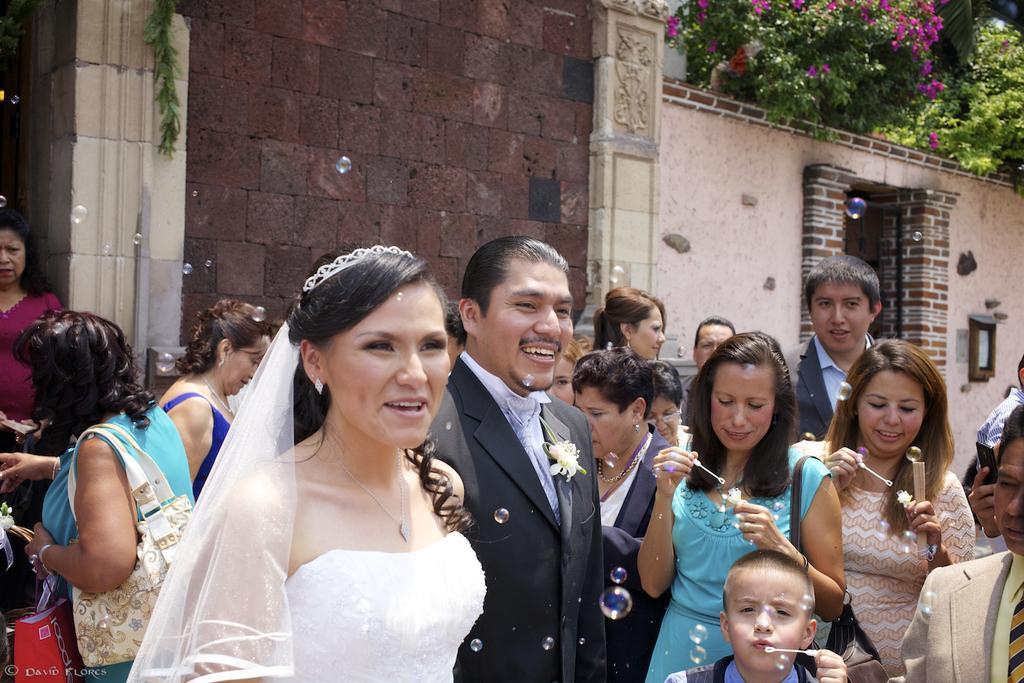In one or two sentences, can you explain what this image depicts? In the center of the image, we can see a bride and a bridegroom and in the background, there are many people and are wearing bags and holding some objects and there is a building and we can see some trees and a board and there are bubbles. 